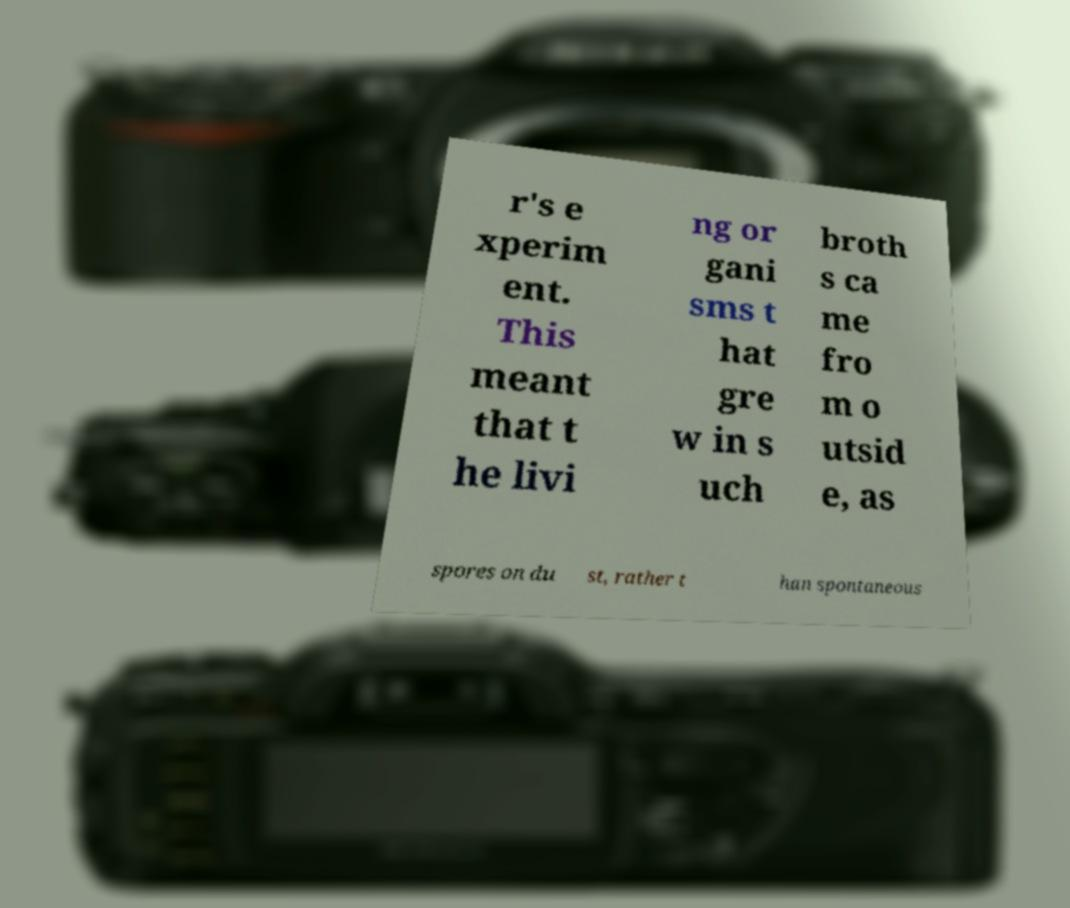Can you accurately transcribe the text from the provided image for me? r's e xperim ent. This meant that t he livi ng or gani sms t hat gre w in s uch broth s ca me fro m o utsid e, as spores on du st, rather t han spontaneous 